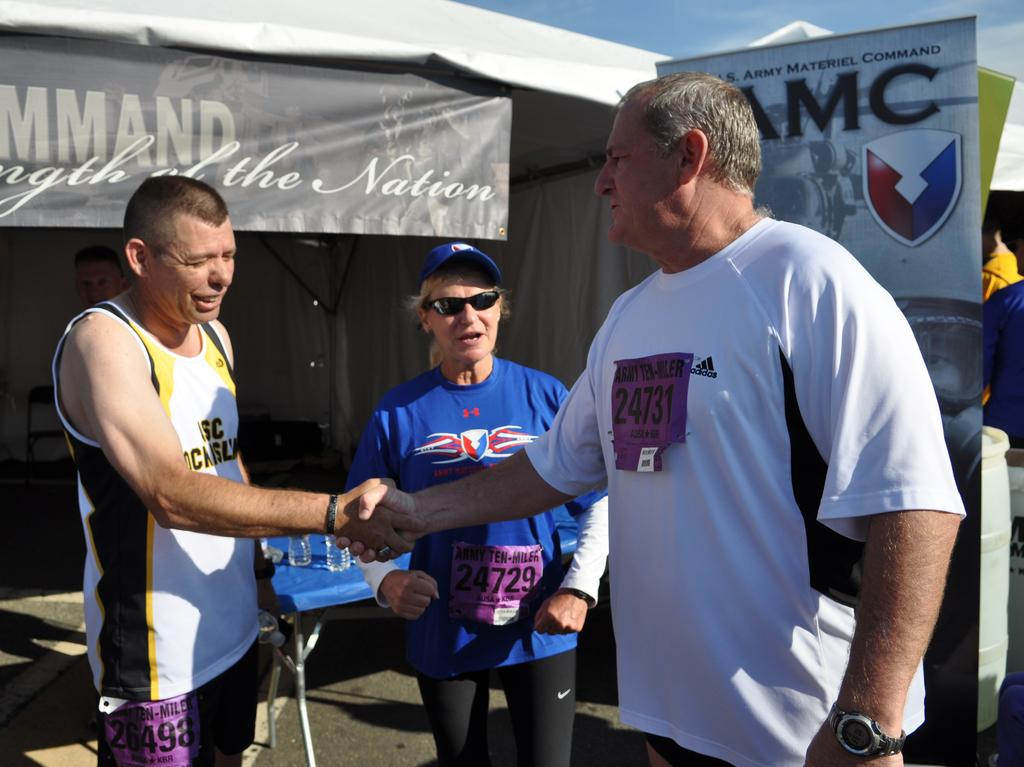<image>
Describe the image concisely. a man standing neat a sign that has MC on it 